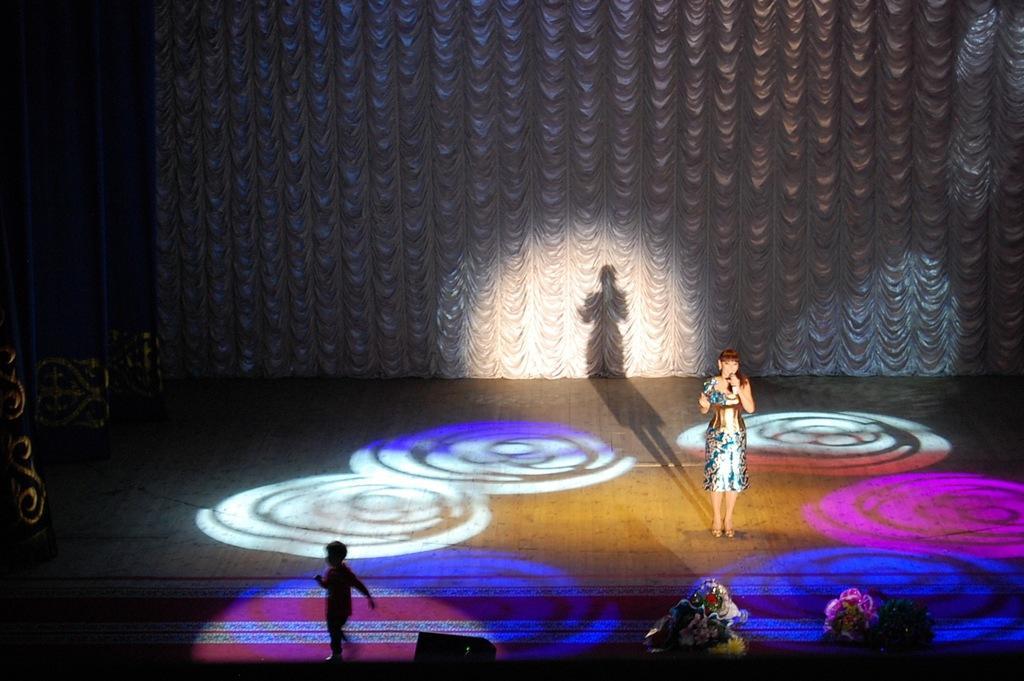Could you give a brief overview of what you see in this image? This is the woman standing and holding a mike. These are the show lights. I can see a boy running. This looks like a stage. I think these are the flower bouquets. I can see the cloth hanging, which is white in color. 